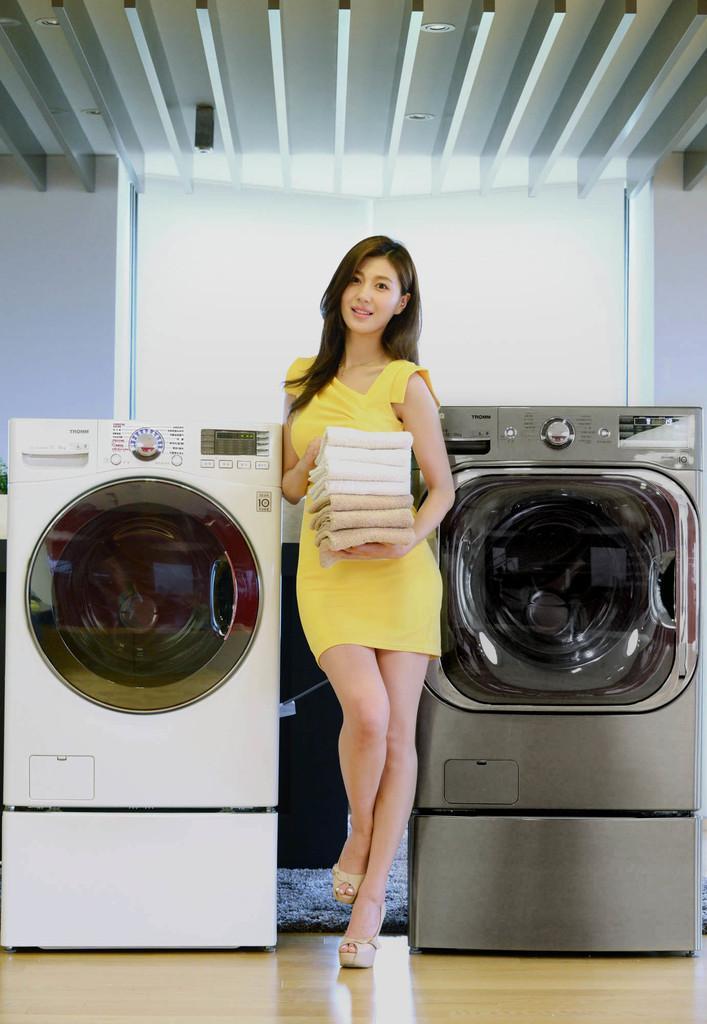Describe this image in one or two sentences. This woman yellow dress and holding clothes. Beside this woman there are washing machines. Floor with carpet. 